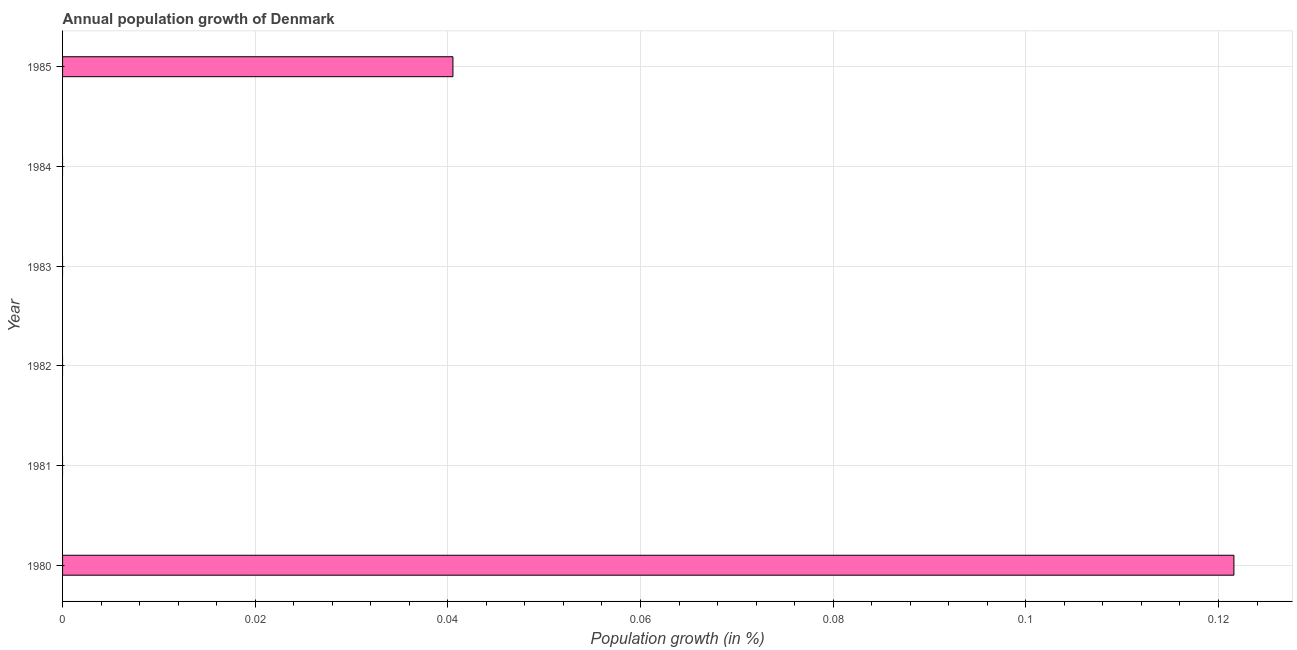Does the graph contain any zero values?
Your answer should be very brief. Yes. Does the graph contain grids?
Your response must be concise. Yes. What is the title of the graph?
Give a very brief answer. Annual population growth of Denmark. What is the label or title of the X-axis?
Provide a short and direct response. Population growth (in %). What is the label or title of the Y-axis?
Your answer should be compact. Year. Across all years, what is the maximum population growth?
Provide a short and direct response. 0.12. Across all years, what is the minimum population growth?
Provide a short and direct response. 0. What is the sum of the population growth?
Make the answer very short. 0.16. What is the difference between the population growth in 1980 and 1985?
Offer a very short reply. 0.08. What is the average population growth per year?
Ensure brevity in your answer.  0.03. What is the median population growth?
Your answer should be compact. 0. In how many years, is the population growth greater than 0.048 %?
Your answer should be compact. 1. What is the difference between the highest and the lowest population growth?
Make the answer very short. 0.12. How many bars are there?
Ensure brevity in your answer.  2. Are the values on the major ticks of X-axis written in scientific E-notation?
Offer a very short reply. No. What is the Population growth (in %) in 1980?
Provide a succinct answer. 0.12. What is the Population growth (in %) in 1981?
Offer a very short reply. 0. What is the Population growth (in %) of 1982?
Your answer should be compact. 0. What is the Population growth (in %) of 1983?
Keep it short and to the point. 0. What is the Population growth (in %) of 1985?
Offer a terse response. 0.04. What is the difference between the Population growth (in %) in 1980 and 1985?
Offer a terse response. 0.08. What is the ratio of the Population growth (in %) in 1980 to that in 1985?
Keep it short and to the point. 3. 